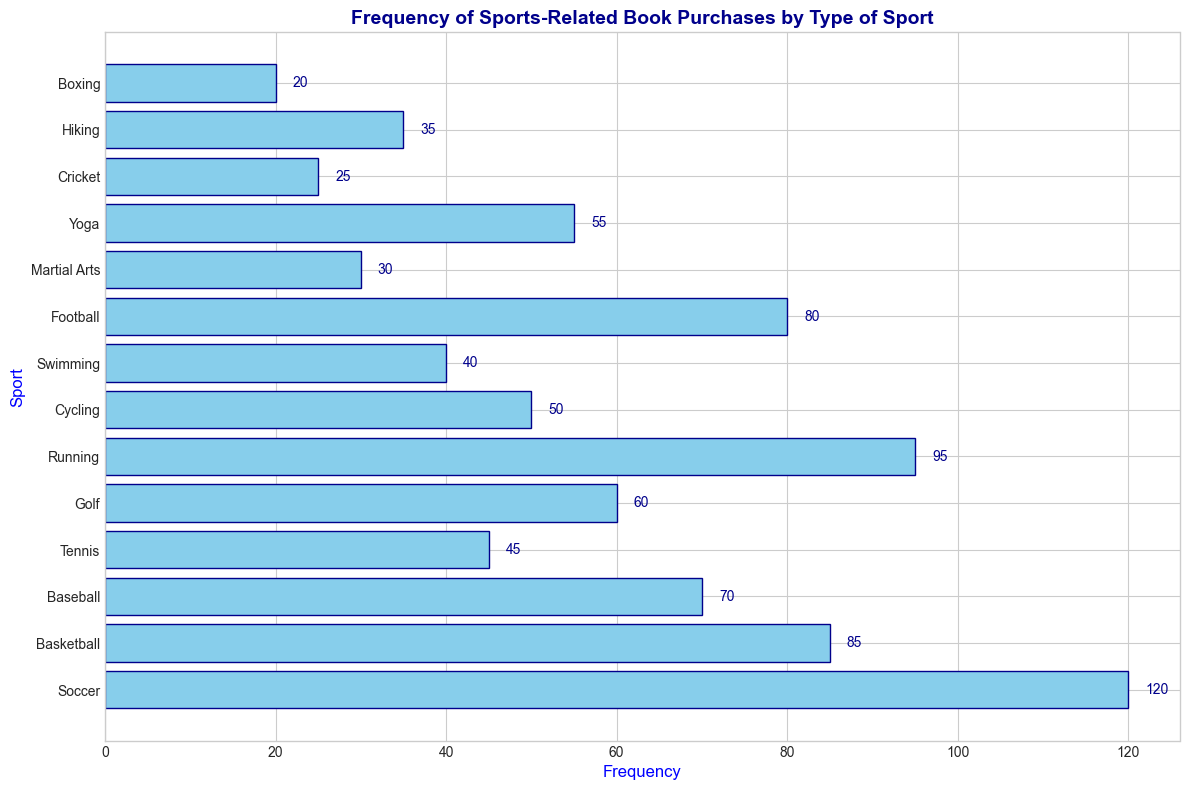What is the most frequently purchased type of sports-related book? By looking at the lengths of the bars, the longest bar represents the most frequently purchased type of sports-related book, which is Soccer with a frequency of 120.
Answer: Soccer Which sport has fewer purchases, Swimming or Hiking? By comparing the lengths of the bars for Swimming and Hiking, Swimming has a frequency of 40 while Hiking has a frequency of 35. Therefore, Hiking has fewer purchases than Swimming.
Answer: Hiking What is the combined frequency of books purchased for Tennis and Golf? The frequency of Tennis is 45 and the frequency of Golf is 60. Adding these together: 45 + 60 = 105.
Answer: 105 Which has more purchases, Basketball or Football? And by how many more? Basketball has a frequency of 85 while Football has a frequency of 80. The difference is 85 - 80 = 5. Therefore, Basketball has 5 more purchases than Football.
Answer: Basketball by 5 What is the average frequency of purchases for Yoga, Cricket, and Boxing? The frequencies are Yoga: 55, Cricket: 25, and Boxing: 20. Summing these: 55 + 25 + 20 = 100. The average is 100/3 ≈ 33.33.
Answer: 33.33 How many sports-related books have a purchase frequency less than 50? By counting bars with a length indicating a frequency below 50, we have: Tennis (45), Swimming (40), Martial Arts (30), Cricket (25), Hiking (35), and Boxing (20). There are 6 such sports.
Answer: 6 Which sport has the least purchases? The shortest bar represents the sport with the least purchases, which is Boxing with a frequency of 20.
Answer: Boxing Is the frequency of Running purchases higher than that of Basketball? By comparing the lengths of the bars, Running has a frequency of 95 while Basketball has a frequency of 85. Running does have a higher frequency than Basketball.
Answer: Yes What is the total number of sports-related book purchases for sports with a frequency of 50 or more? The sports with a frequency of 50 or more are Soccer: 120, Basketball: 85, Baseball: 70, Running: 95, Football: 80, Golf: 60, and Yoga: 55. Adding these: 120 + 85 + 70 + 95 + 80 + 60 + 55 = 565.
Answer: 565 Which sports have exactly the same frequency of related book purchases? By inspecting the lengths of the bars, no two bars appear to have the exact same length, hence no sports have the same frequency of related book purchases.
Answer: None 